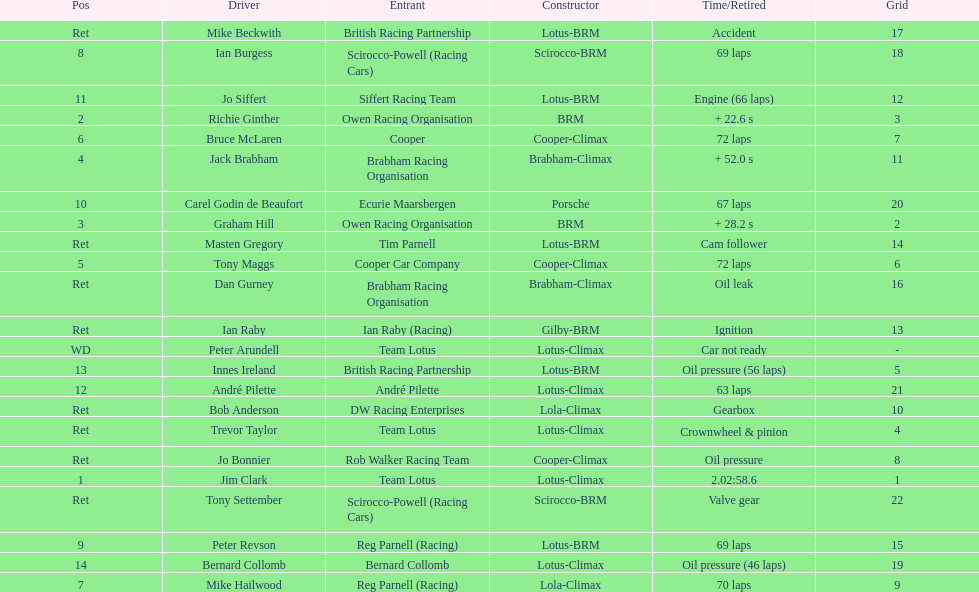What country had the least number of drivers, germany or the uk? Germany. 